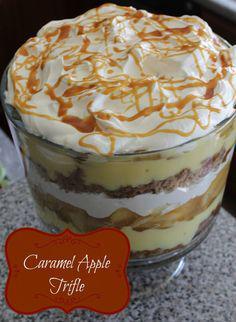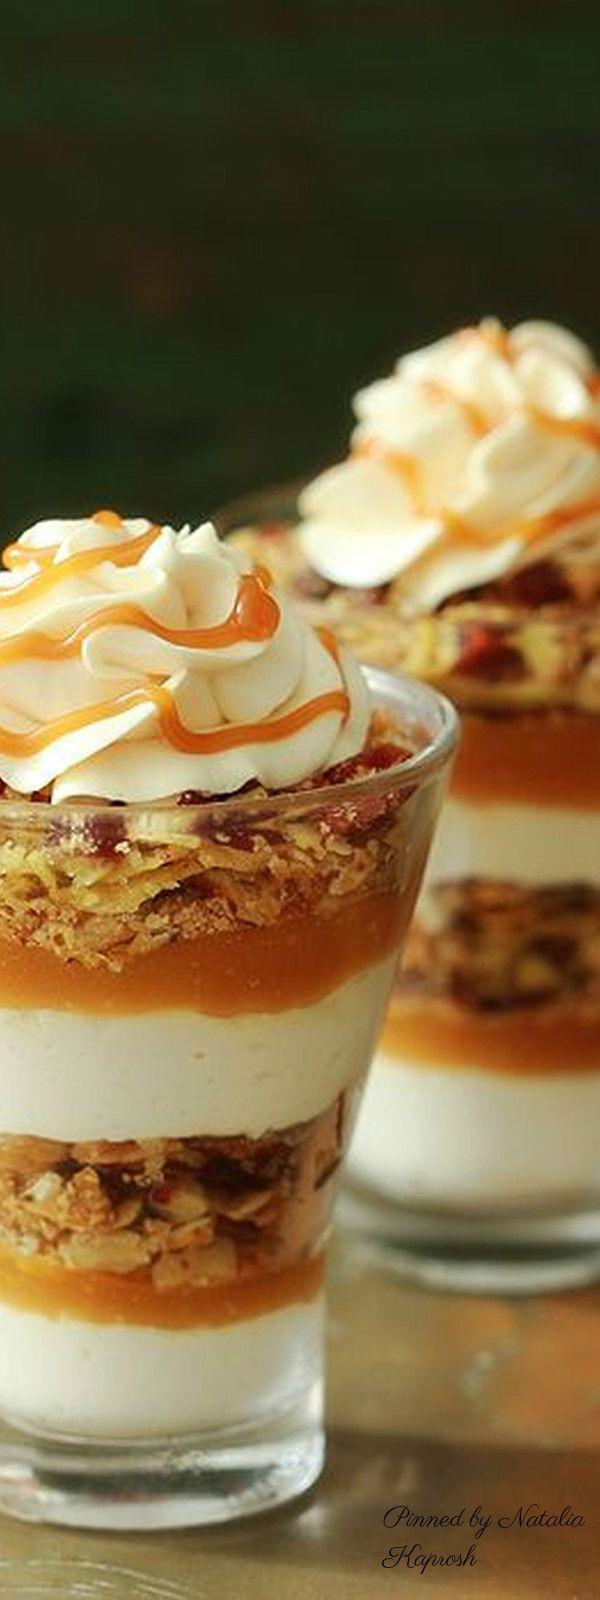The first image is the image on the left, the second image is the image on the right. Analyze the images presented: Is the assertion "There is caramel drizzled atop the desert in the image on the left." valid? Answer yes or no. Yes. The first image is the image on the left, the second image is the image on the right. Evaluate the accuracy of this statement regarding the images: "Two large fancy layered desserts are in footed bowls.". Is it true? Answer yes or no. No. 